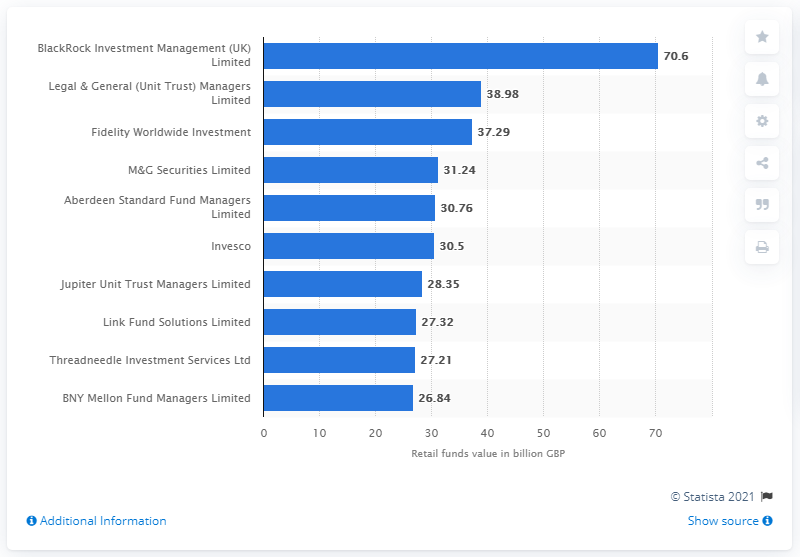Indicate a few pertinent items in this graphic. In November 2019, BlackRock Investment Management (UK) Limited was the top fund management company in the UK. 